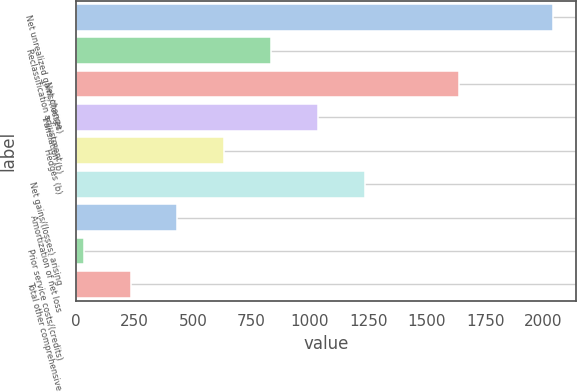Convert chart. <chart><loc_0><loc_0><loc_500><loc_500><bar_chart><fcel>Net unrealized gains/(losses)<fcel>Reclassification adjustment<fcel>Net change<fcel>Translation (b)<fcel>Hedges (b)<fcel>Net gains/(losses) arising<fcel>Amortization of net loss<fcel>Prior service costs/(credits)<fcel>Total other comprehensive<nl><fcel>2039<fcel>834.8<fcel>1637.6<fcel>1035.5<fcel>634.1<fcel>1236.2<fcel>433.4<fcel>32<fcel>232.7<nl></chart> 